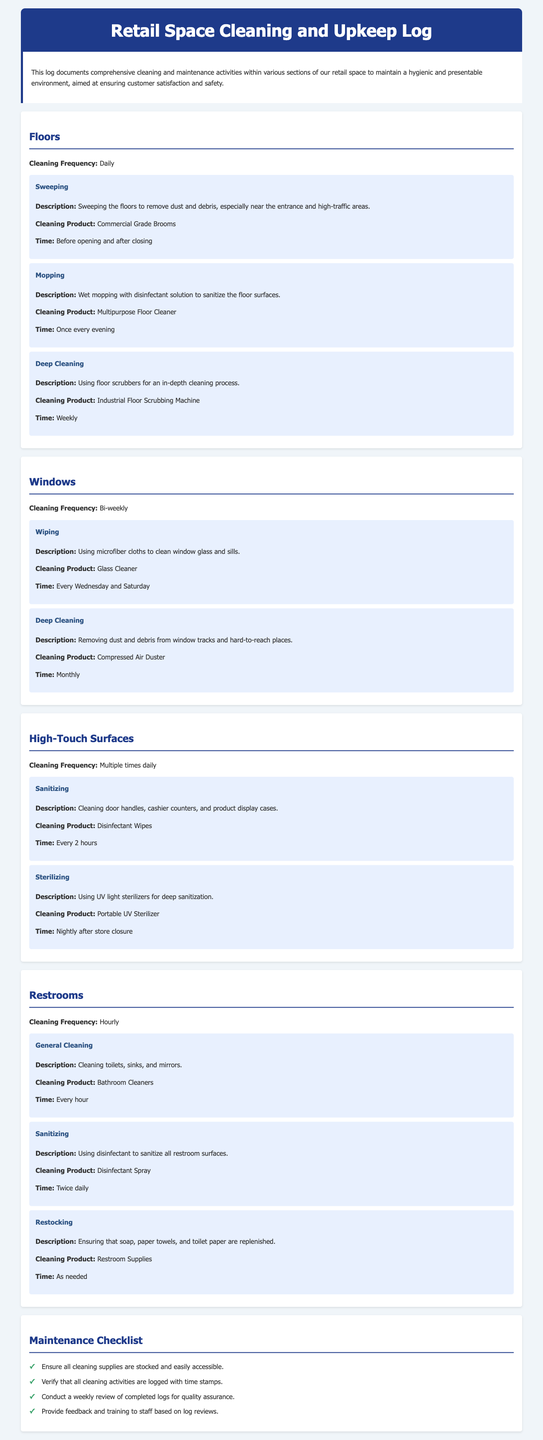what is the cleaning frequency for floors? The cleaning frequency for floors is mentioned as daily.
Answer: Daily what cleaning product is used for mopping? The document specifies that a multipurpose floor cleaner is used for mopping.
Answer: Multipurpose Floor Cleaner how often are high-touch surfaces sanitized? High-touch surfaces are sanitized multiple times daily according to the log.
Answer: Multiple times daily what is the time scheduled for window wiping? The scheduled time for window wiping is every Wednesday and Saturday.
Answer: Every Wednesday and Saturday what cleaning method is performed nightly for high-touch surfaces? The nightly cleaning method used for high-touch surfaces is sterilizing with a portable UV sterilizer.
Answer: Sterilizing how frequently are restrooms cleaned? The cleaning frequency for restrooms is hourly as mentioned in the log.
Answer: Hourly what item is required to clean window tracks? The document states that a compressed air duster is used to clean window tracks.
Answer: Compressed Air Duster how often should a review of the maintenance logs be conducted? The document specifies that a weekly review of completed logs is required for quality assurance.
Answer: Weekly what does the maintenance checklist item about cleaning supplies state? The maintenance checklist states that all cleaning supplies should be stocked and easily accessible.
Answer: Ensure all cleaning supplies are stocked and easily accessible 